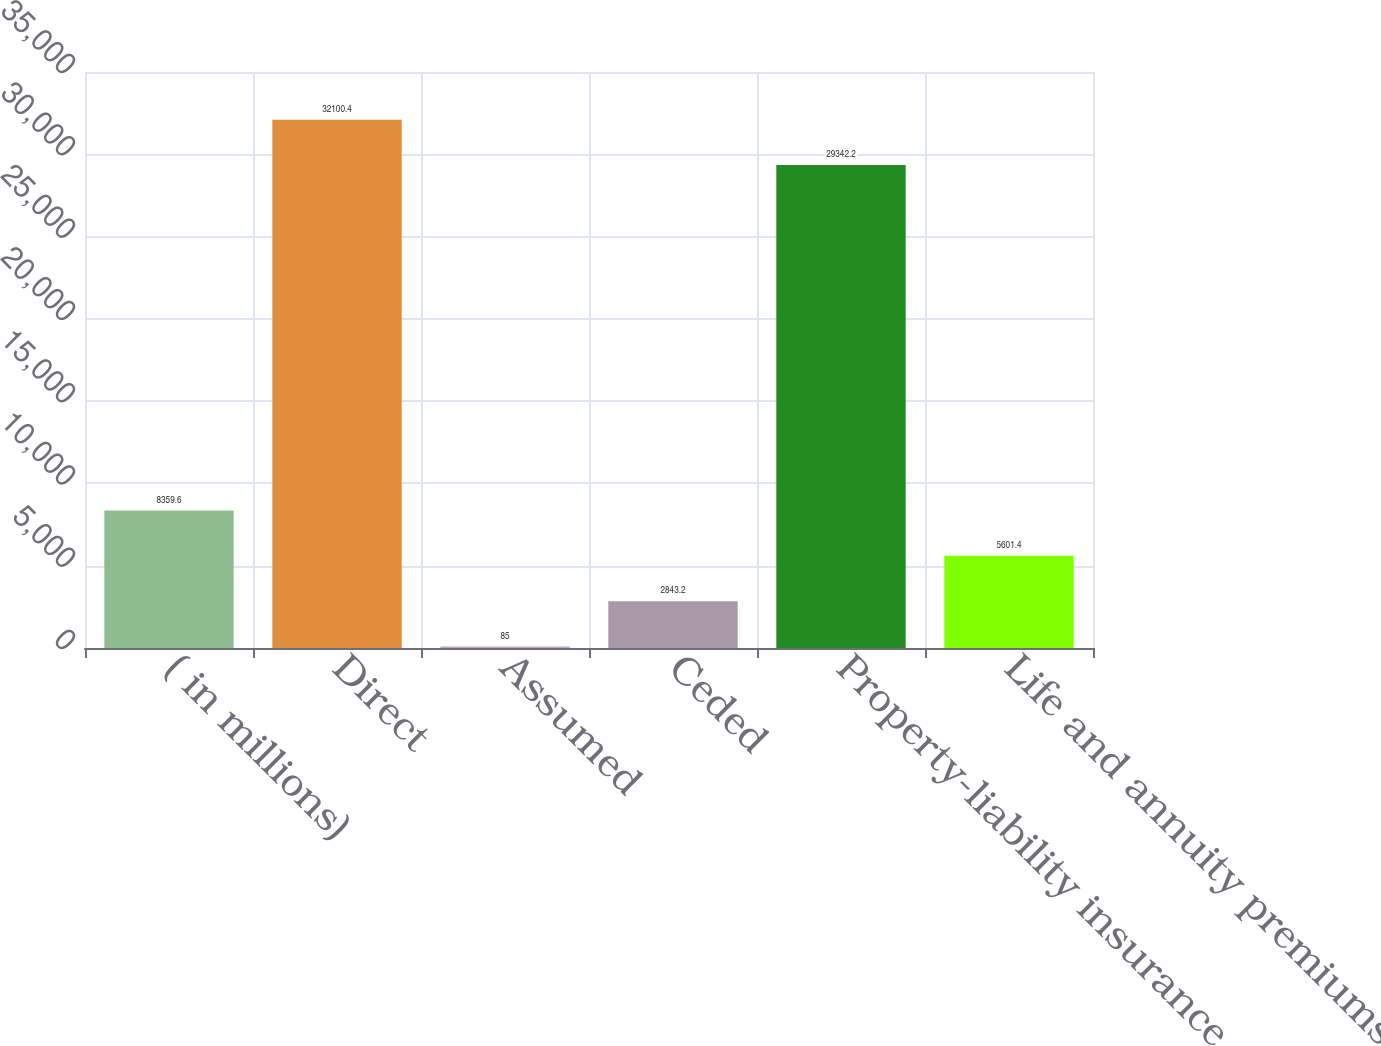Convert chart. <chart><loc_0><loc_0><loc_500><loc_500><bar_chart><fcel>( in millions)<fcel>Direct<fcel>Assumed<fcel>Ceded<fcel>Property-liability insurance<fcel>Life and annuity premiums and<nl><fcel>8359.6<fcel>32100.4<fcel>85<fcel>2843.2<fcel>29342.2<fcel>5601.4<nl></chart> 